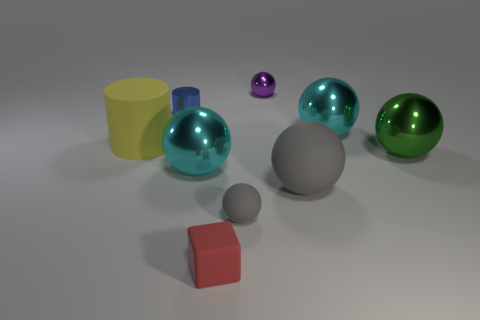Subtract all large green shiny spheres. How many spheres are left? 5 Add 1 yellow rubber things. How many yellow rubber things are left? 2 Add 5 large green metal spheres. How many large green metal spheres exist? 6 Add 1 large brown metallic cylinders. How many objects exist? 10 Subtract all cyan spheres. How many spheres are left? 4 Subtract 0 purple cubes. How many objects are left? 9 Subtract all blocks. How many objects are left? 8 Subtract 2 cylinders. How many cylinders are left? 0 Subtract all purple blocks. Subtract all gray balls. How many blocks are left? 1 Subtract all green cubes. How many purple cylinders are left? 0 